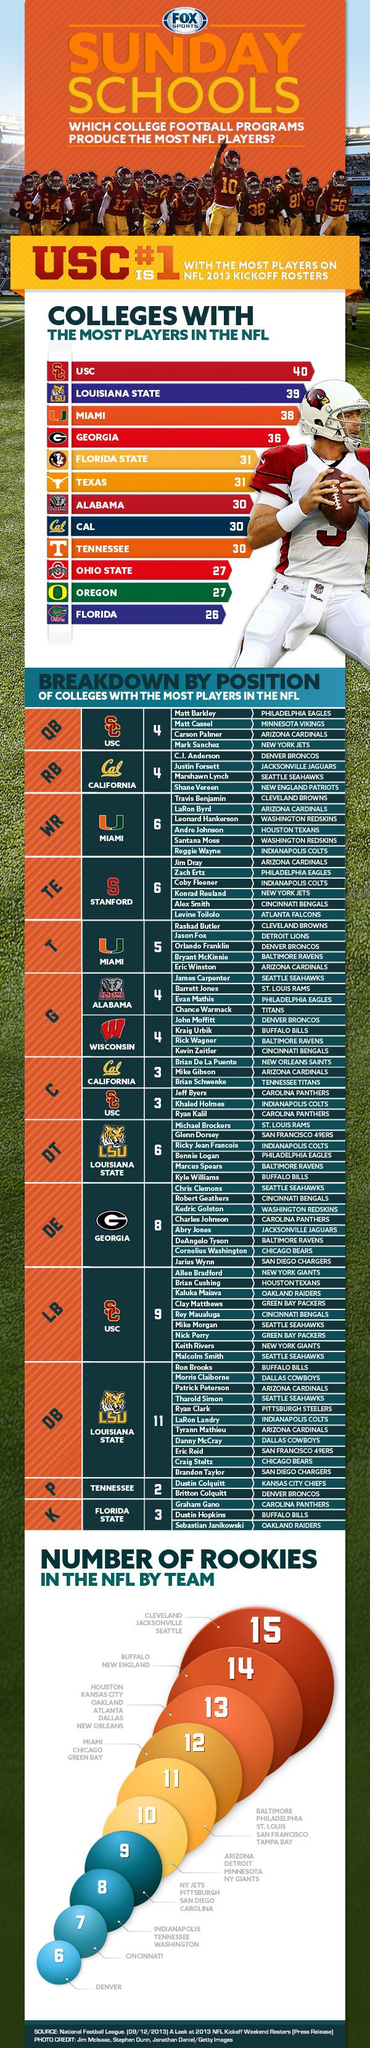Highlight a few significant elements in this photo. The Buffalo Bills have four players on their team. The total number of defensive backs and defensive tacklers from LSU is 17. The Carolina Panthers have two players who play the center position: Jeff Byers and Ryan Kalil. According to the Green Bay Packers, there are currently two linebackers on their roster. There are three center positions available from the Southern California University. 